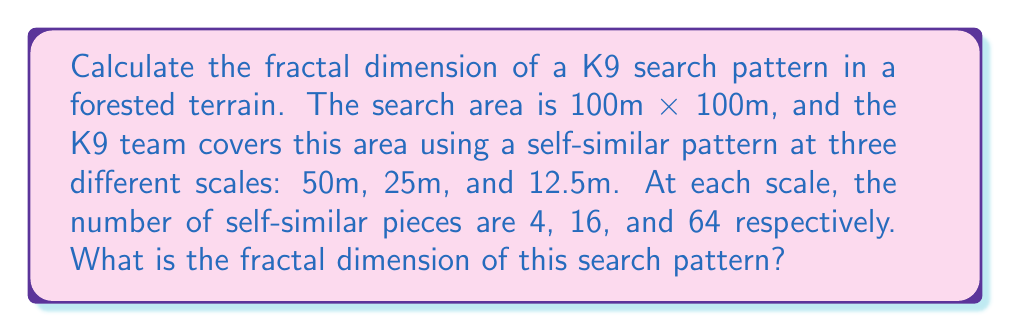Can you solve this math problem? To calculate the fractal dimension of the K9 search pattern, we'll use the box-counting method, which is a common technique in fractal analysis. The fractal dimension $D$ is given by the formula:

$$ D = \frac{\log(N)}{\log(1/r)} $$

Where $N$ is the number of self-similar pieces and $r$ is the scale factor.

Step 1: Identify the scale factors ($r$) and number of pieces ($N$) for each scale:
- Scale 1: $r_1 = 50/100 = 1/2$, $N_1 = 4$
- Scale 2: $r_2 = 25/100 = 1/4$, $N_2 = 16$
- Scale 3: $r_3 = 12.5/100 = 1/8$, $N_3 = 64$

Step 2: Calculate $D$ for each scale:

For scale 1:
$$ D_1 = \frac{\log(4)}{\log(2)} = 2 $$

For scale 2:
$$ D_2 = \frac{\log(16)}{\log(4)} = 2 $$

For scale 3:
$$ D_3 = \frac{\log(64)}{\log(8)} = 2 $$

Step 3: Verify that the fractal dimension is consistent across all scales.

We can see that $D_1 = D_2 = D_3 = 2$, which confirms that the search pattern has a consistent fractal dimension across all scales.

Therefore, the fractal dimension of the K9 search pattern in this forested terrain is 2.
Answer: $D = 2$ 